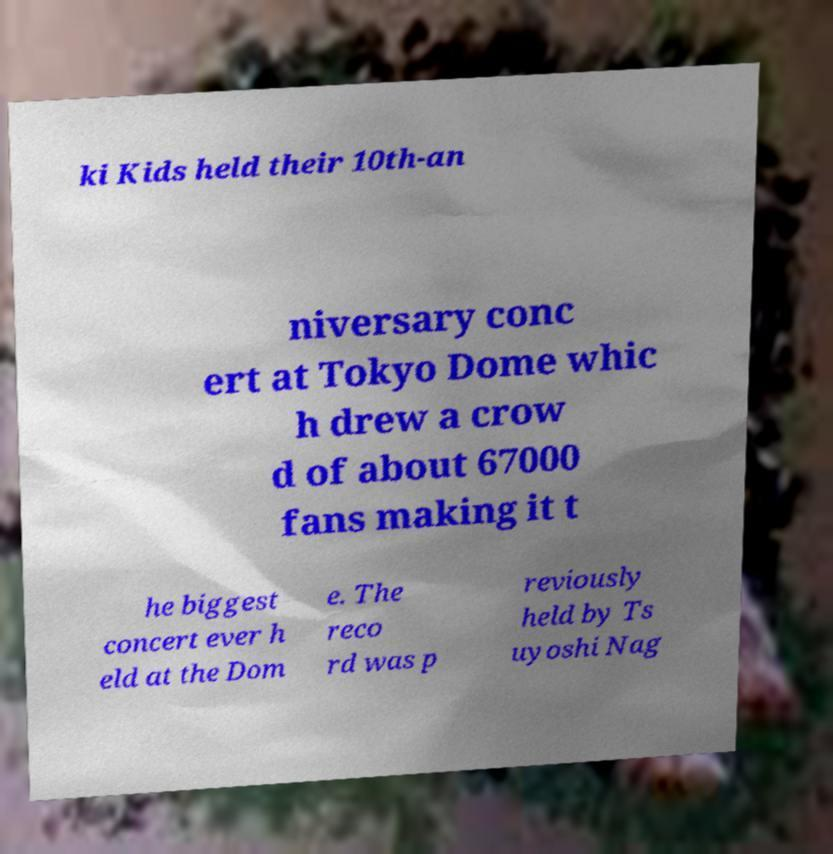Can you read and provide the text displayed in the image?This photo seems to have some interesting text. Can you extract and type it out for me? ki Kids held their 10th-an niversary conc ert at Tokyo Dome whic h drew a crow d of about 67000 fans making it t he biggest concert ever h eld at the Dom e. The reco rd was p reviously held by Ts uyoshi Nag 